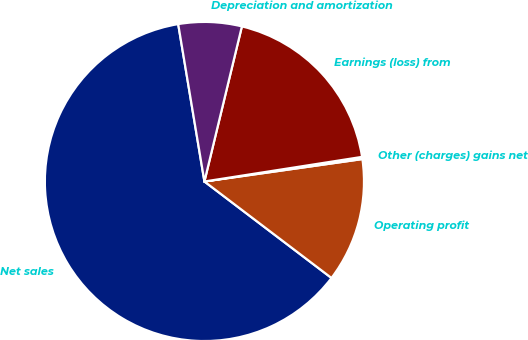<chart> <loc_0><loc_0><loc_500><loc_500><pie_chart><fcel>Net sales<fcel>Operating profit<fcel>Other (charges) gains net<fcel>Earnings (loss) from<fcel>Depreciation and amortization<nl><fcel>62.03%<fcel>12.58%<fcel>0.22%<fcel>18.76%<fcel>6.4%<nl></chart> 